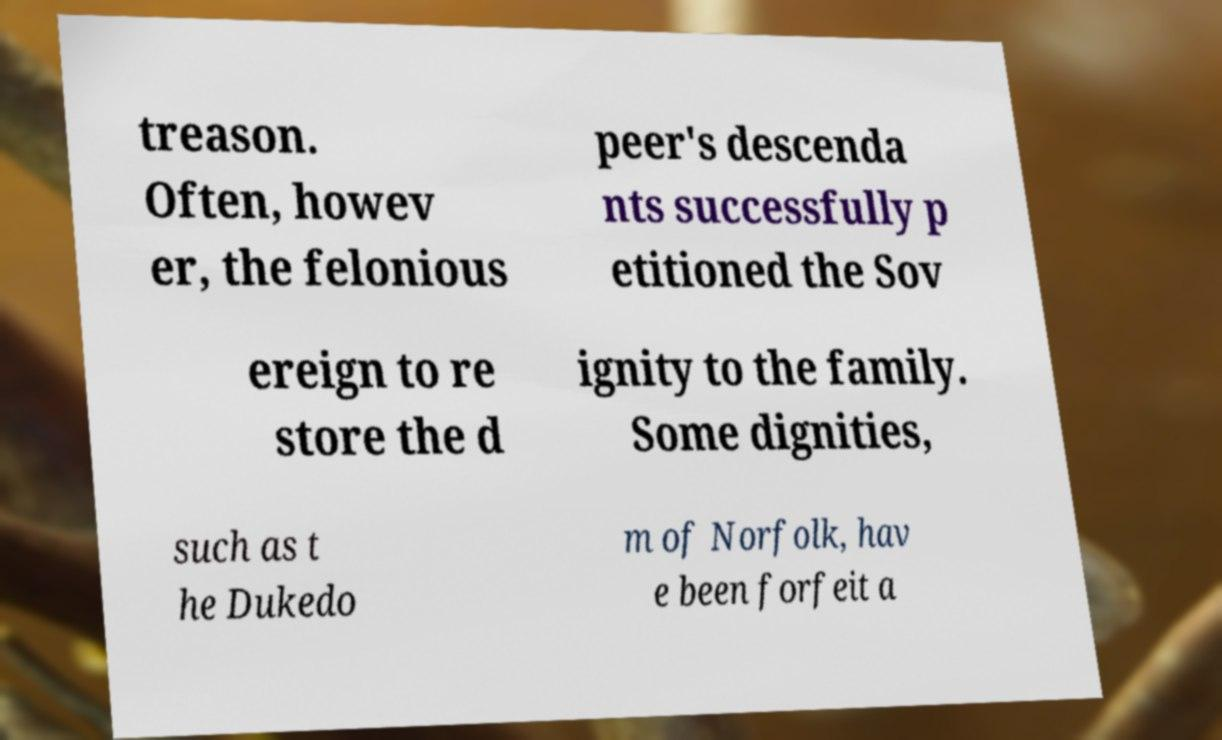Could you assist in decoding the text presented in this image and type it out clearly? treason. Often, howev er, the felonious peer's descenda nts successfully p etitioned the Sov ereign to re store the d ignity to the family. Some dignities, such as t he Dukedo m of Norfolk, hav e been forfeit a 